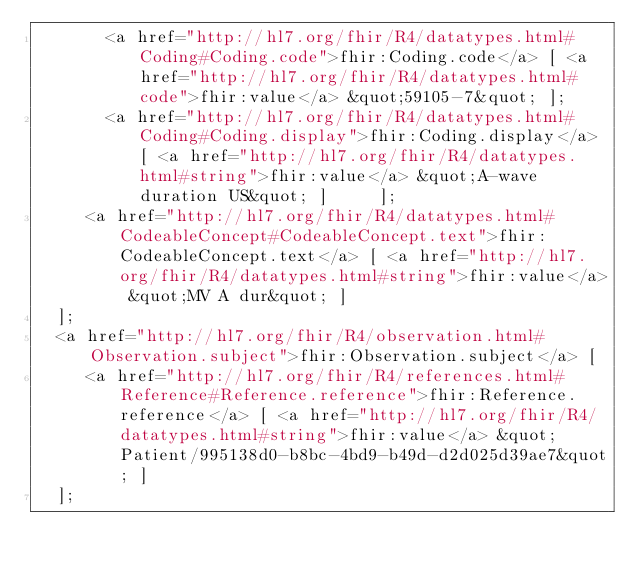Convert code to text. <code><loc_0><loc_0><loc_500><loc_500><_HTML_>       <a href="http://hl7.org/fhir/R4/datatypes.html#Coding#Coding.code">fhir:Coding.code</a> [ <a href="http://hl7.org/fhir/R4/datatypes.html#code">fhir:value</a> &quot;59105-7&quot; ];
       <a href="http://hl7.org/fhir/R4/datatypes.html#Coding#Coding.display">fhir:Coding.display</a> [ <a href="http://hl7.org/fhir/R4/datatypes.html#string">fhir:value</a> &quot;A-wave duration US&quot; ]     ];
     <a href="http://hl7.org/fhir/R4/datatypes.html#CodeableConcept#CodeableConcept.text">fhir:CodeableConcept.text</a> [ <a href="http://hl7.org/fhir/R4/datatypes.html#string">fhir:value</a> &quot;MV A dur&quot; ]
  ];
  <a href="http://hl7.org/fhir/R4/observation.html#Observation.subject">fhir:Observation.subject</a> [
     <a href="http://hl7.org/fhir/R4/references.html#Reference#Reference.reference">fhir:Reference.reference</a> [ <a href="http://hl7.org/fhir/R4/datatypes.html#string">fhir:value</a> &quot;Patient/995138d0-b8bc-4bd9-b49d-d2d025d39ae7&quot; ]
  ];</code> 